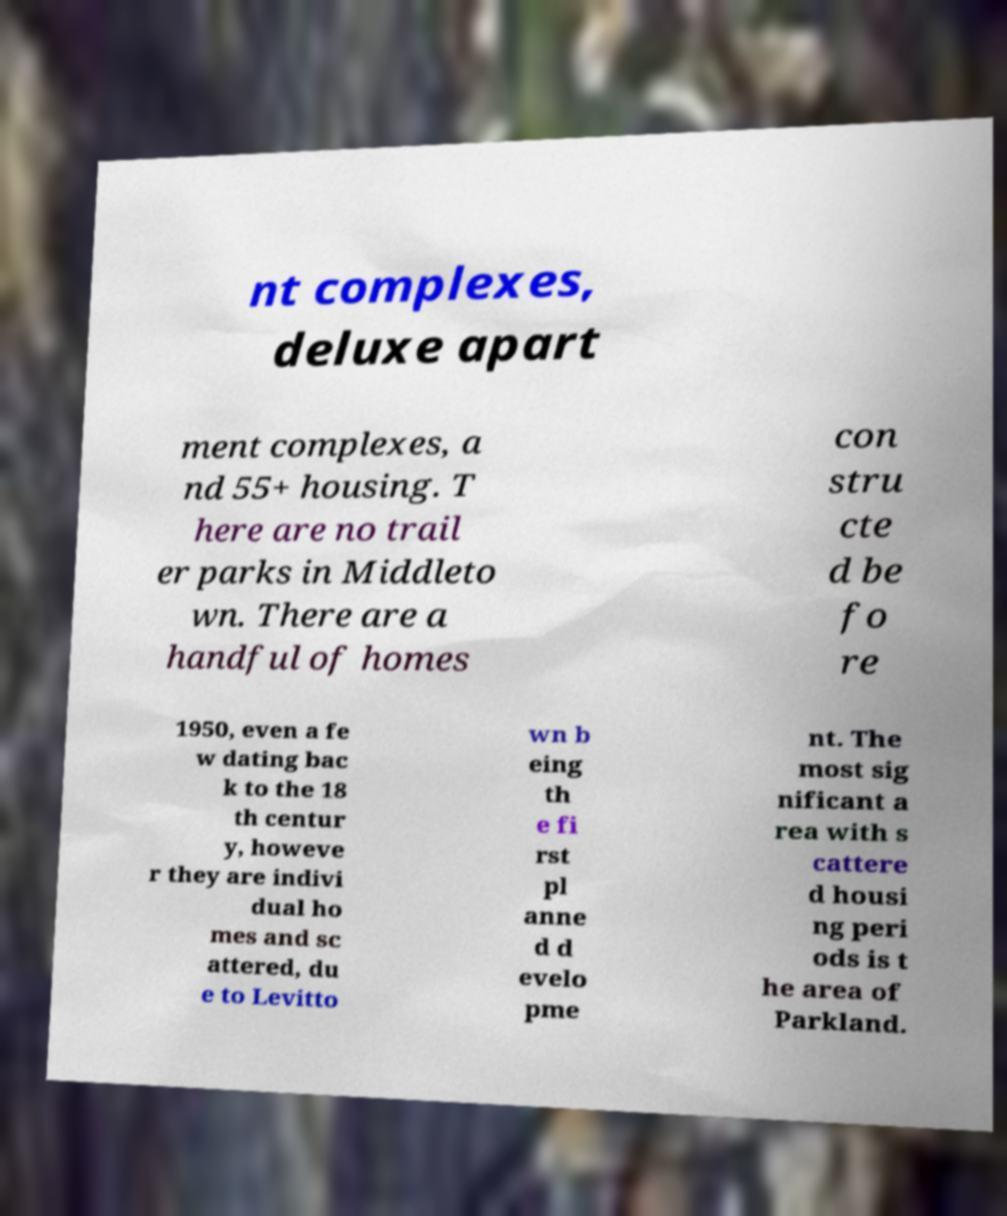There's text embedded in this image that I need extracted. Can you transcribe it verbatim? nt complexes, deluxe apart ment complexes, a nd 55+ housing. T here are no trail er parks in Middleto wn. There are a handful of homes con stru cte d be fo re 1950, even a fe w dating bac k to the 18 th centur y, howeve r they are indivi dual ho mes and sc attered, du e to Levitto wn b eing th e fi rst pl anne d d evelo pme nt. The most sig nificant a rea with s cattere d housi ng peri ods is t he area of Parkland. 